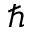Convert formula to latex. <formula><loc_0><loc_0><loc_500><loc_500>\hslash</formula> 